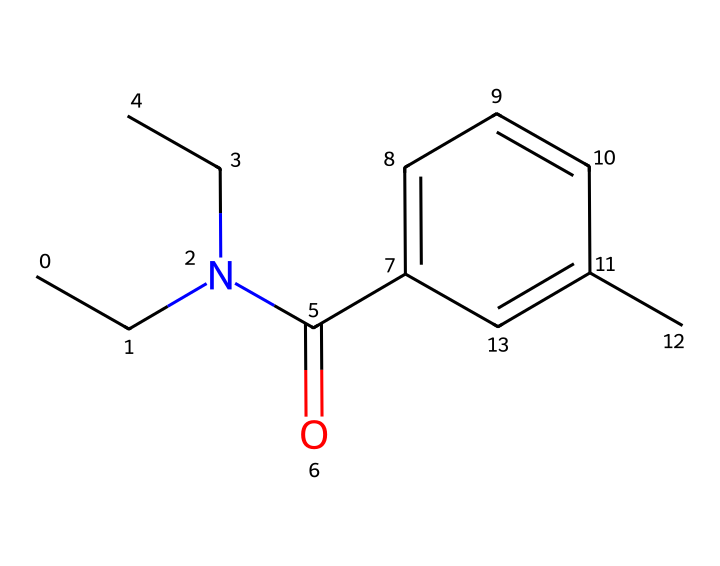What is the molecular formula of this compound? To determine the molecular formula from the SMILES representation provided, you need to count the atoms of each element indicated in the structure. The SMILES shows carbon (C), nitrogen (N), and oxygen (O) atoms. Counting these gives 13 carbon atoms, 2 nitrogen atoms, and 1 oxygen atom. Thus, the molecular formula is C13H17N2O.
Answer: C13H17N2O How many nitrogen atoms are present in this molecule? Look for the nitrogen symbols (N) in the SMILES notation. There are two occurrences of nitrogen in the structure. Therefore, the total count of nitrogen atoms is 2.
Answer: 2 Is this compound a primary, secondary, or tertiary amine? The structure shows a nitrogen atom bonded to two carbon groups and a carbonyl group, indicating that it is a secondary amine. This classification is based on the nitrogen atom being attached to two alkyl groups.
Answer: secondary amine What functional group is indicated by 'C(=O)' in the structure? The notation 'C(=O)' refers to a carbon atom double-bonded to an oxygen atom, which indicates the presence of a carbonyl group. This carbonyl group signifies that the compound has either a ketone or an amide functional group. In this case, it leads to a characteristic of an amide functional group because of its connection to the nitrogen atom.
Answer: amide What type of phosphorus compound does this represent? This compound does not directly represent a phosphorus compound since it primarily contains carbon, nitrogen, and oxygen. Phosphorus-containing compounds often include esters or phosphates. Therefore, since no phosphorus is found in this specific chemical structure, it cannot be classified accordingly.
Answer: not a phosphorus compound 